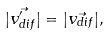Convert formula to latex. <formula><loc_0><loc_0><loc_500><loc_500>| \vec { v _ { d i f } ^ { \prime } } | = | \vec { v _ { d i f } } | ,</formula> 